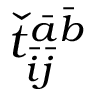Convert formula to latex. <formula><loc_0><loc_0><loc_500><loc_500>\check { t } _ { \bar { i } \bar { j } } ^ { \bar { a } \bar { b } }</formula> 